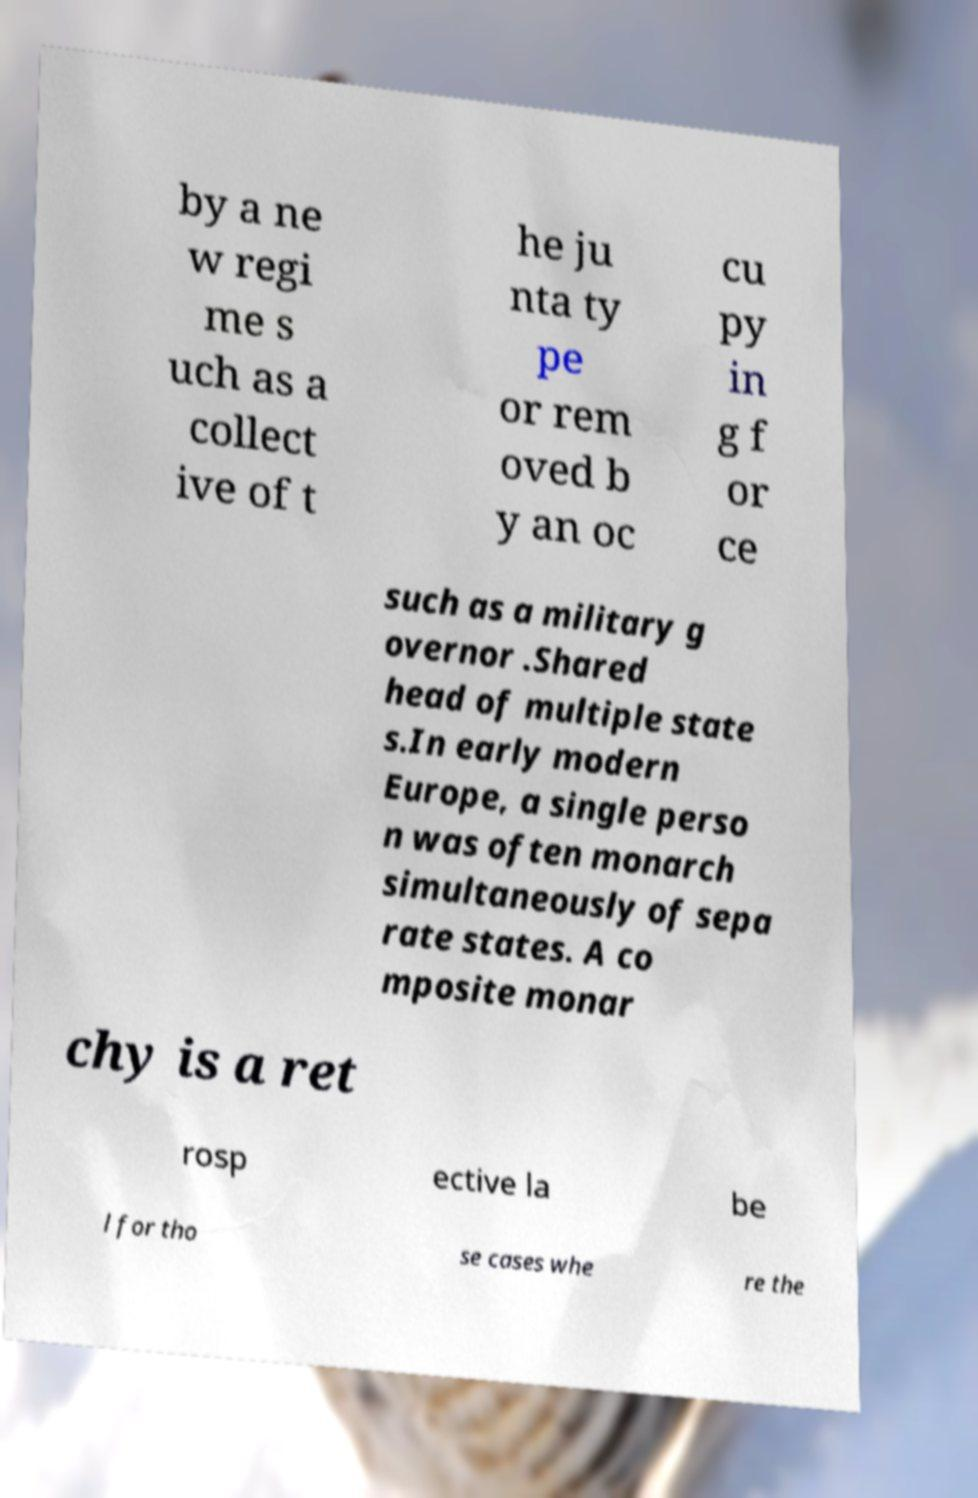There's text embedded in this image that I need extracted. Can you transcribe it verbatim? by a ne w regi me s uch as a collect ive of t he ju nta ty pe or rem oved b y an oc cu py in g f or ce such as a military g overnor .Shared head of multiple state s.In early modern Europe, a single perso n was often monarch simultaneously of sepa rate states. A co mposite monar chy is a ret rosp ective la be l for tho se cases whe re the 